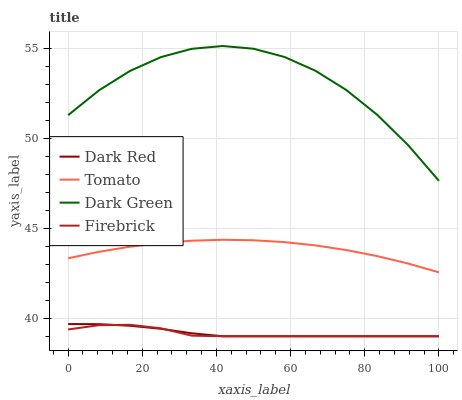Does Firebrick have the minimum area under the curve?
Answer yes or no. Yes. Does Dark Green have the maximum area under the curve?
Answer yes or no. Yes. Does Dark Red have the minimum area under the curve?
Answer yes or no. No. Does Dark Red have the maximum area under the curve?
Answer yes or no. No. Is Dark Red the smoothest?
Answer yes or no. Yes. Is Dark Green the roughest?
Answer yes or no. Yes. Is Firebrick the smoothest?
Answer yes or no. No. Is Firebrick the roughest?
Answer yes or no. No. Does Dark Green have the lowest value?
Answer yes or no. No. Does Dark Green have the highest value?
Answer yes or no. Yes. Does Dark Red have the highest value?
Answer yes or no. No. Is Firebrick less than Tomato?
Answer yes or no. Yes. Is Dark Green greater than Tomato?
Answer yes or no. Yes. Does Firebrick intersect Dark Red?
Answer yes or no. Yes. Is Firebrick less than Dark Red?
Answer yes or no. No. Is Firebrick greater than Dark Red?
Answer yes or no. No. Does Firebrick intersect Tomato?
Answer yes or no. No. 